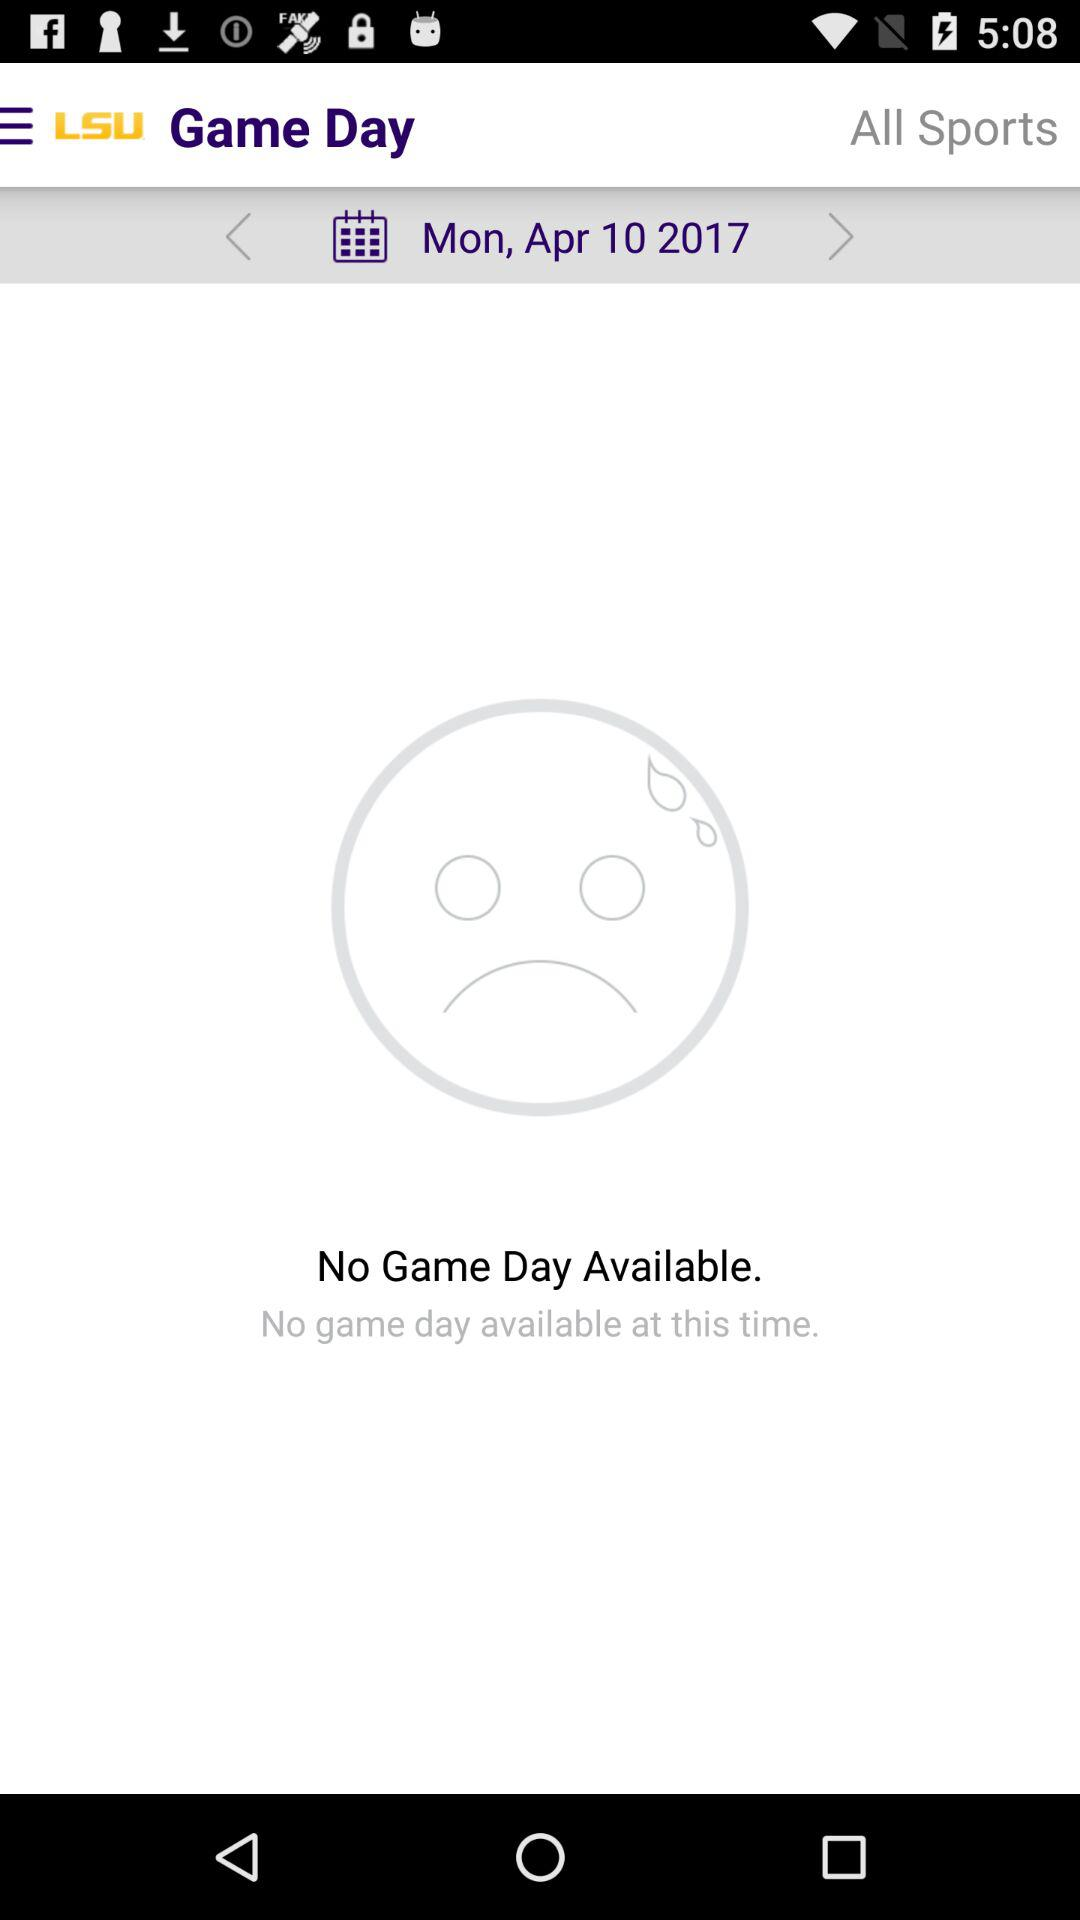What is the date? The date is Monday, April 10, 2017. 